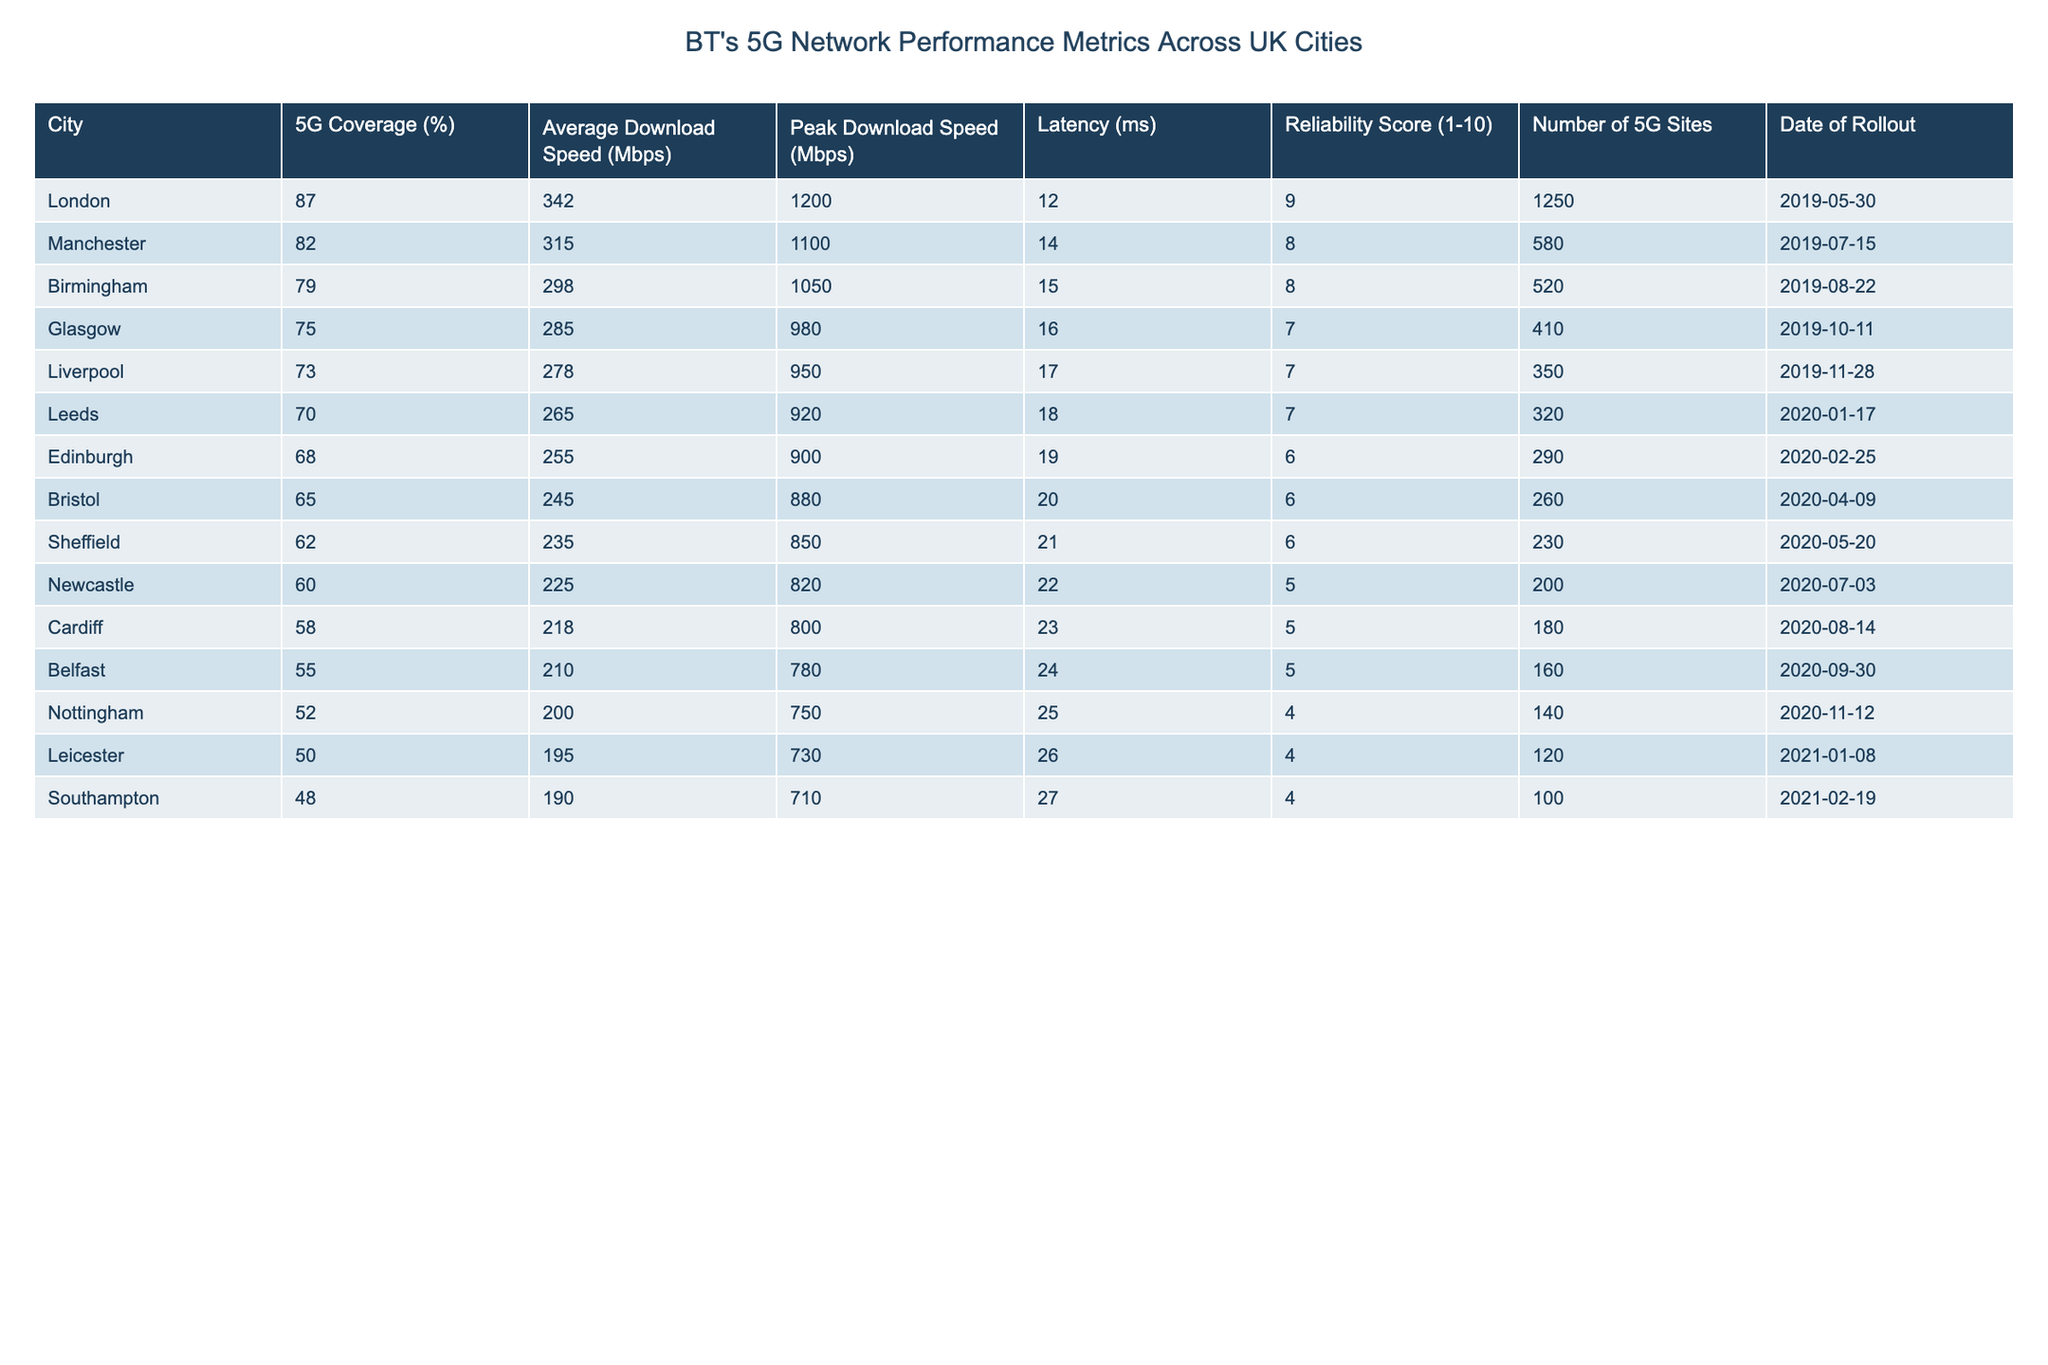What city has the highest 5G coverage percentage? Looking at the table, London has a 5G coverage of 87%, which is the highest compared to all other cities listed.
Answer: London What is the average download speed across all cities? To find the average download speed, sum up all the average download speeds: (342 + 315 + 298 + 285 + 278 + 265 + 255 + 245 + 235 + 225 + 218 + 210 + 200 + 195 + 190) = 4,174. There are 15 cities, so the average download speed is 4,174/15 = 278.27 Mbps.
Answer: 278.27 Mbps Which city has the lowest latency? By reviewing the latency values in the table, Southampton has the lowest latency at 27 ms, which is less than all other cities.
Answer: Southampton Is the average download speed in Edinburgh better than in Birmingham? Edinburgh has an average download speed of 255 Mbps, while Birmingham has 298 Mbps. Therefore, the average download speed in Edinburgh is not better than in Birmingham.
Answer: No What is the difference in the number of 5G sites between London and Leicester? London has 1,250 sites and Leicester has 120 sites. The difference is calculated as 1,250 - 120 = 1,130.
Answer: 1,130 Which city has the highest reliability score, and what is that score? Examining the reliability scores, London has the highest score of 9, which is greater than all other cities listed.
Answer: 9 (London) How does the latency in Manchester compare to the latency in Liverpool? Manchester has a latency of 14 ms, while Liverpool has a latency of 17 ms. Manchester's latency is lower than that of Liverpool.
Answer: Manchester If we consider only the cities with over 70% 5G coverage, what is the average peak download speed? The cities with over 70% coverage are London, Manchester, Birmingham, Glasgow, and Liverpool. Their peak download speeds are: 1200, 1100, 1050, 980, and 950 Mbps. The sum is (1200 + 1100 + 1050 + 980 + 950) = 5,280. The average is 5,280/5 = 1,056 Mbps.
Answer: 1,056 Mbps Was the rollout date in Nottingham later than in Bristol? Nottingham was rolled out on 2020-11-12, while Bristol's rollout was on 2020-04-09. Since November comes after April, Nottingham’s rollout date is later than Bristol's.
Answer: Yes What city has a higher average download speed: Leeds or Newcastle? Leeds has an average download speed of 265 Mbps, while Newcastle has 225 Mbps. Therefore, Leeds has a higher average download speed compared to Newcastle.
Answer: Leeds What is the relationship between the number of 5G sites and 5G coverage percentage? By comparing the data points, higher numbers of 5G sites generally correlate with higher coverage percentages. For example, London has the most sites (1250) and the highest coverage (87%). This suggests a positive relationship between the two variables.
Answer: Positive relationship 